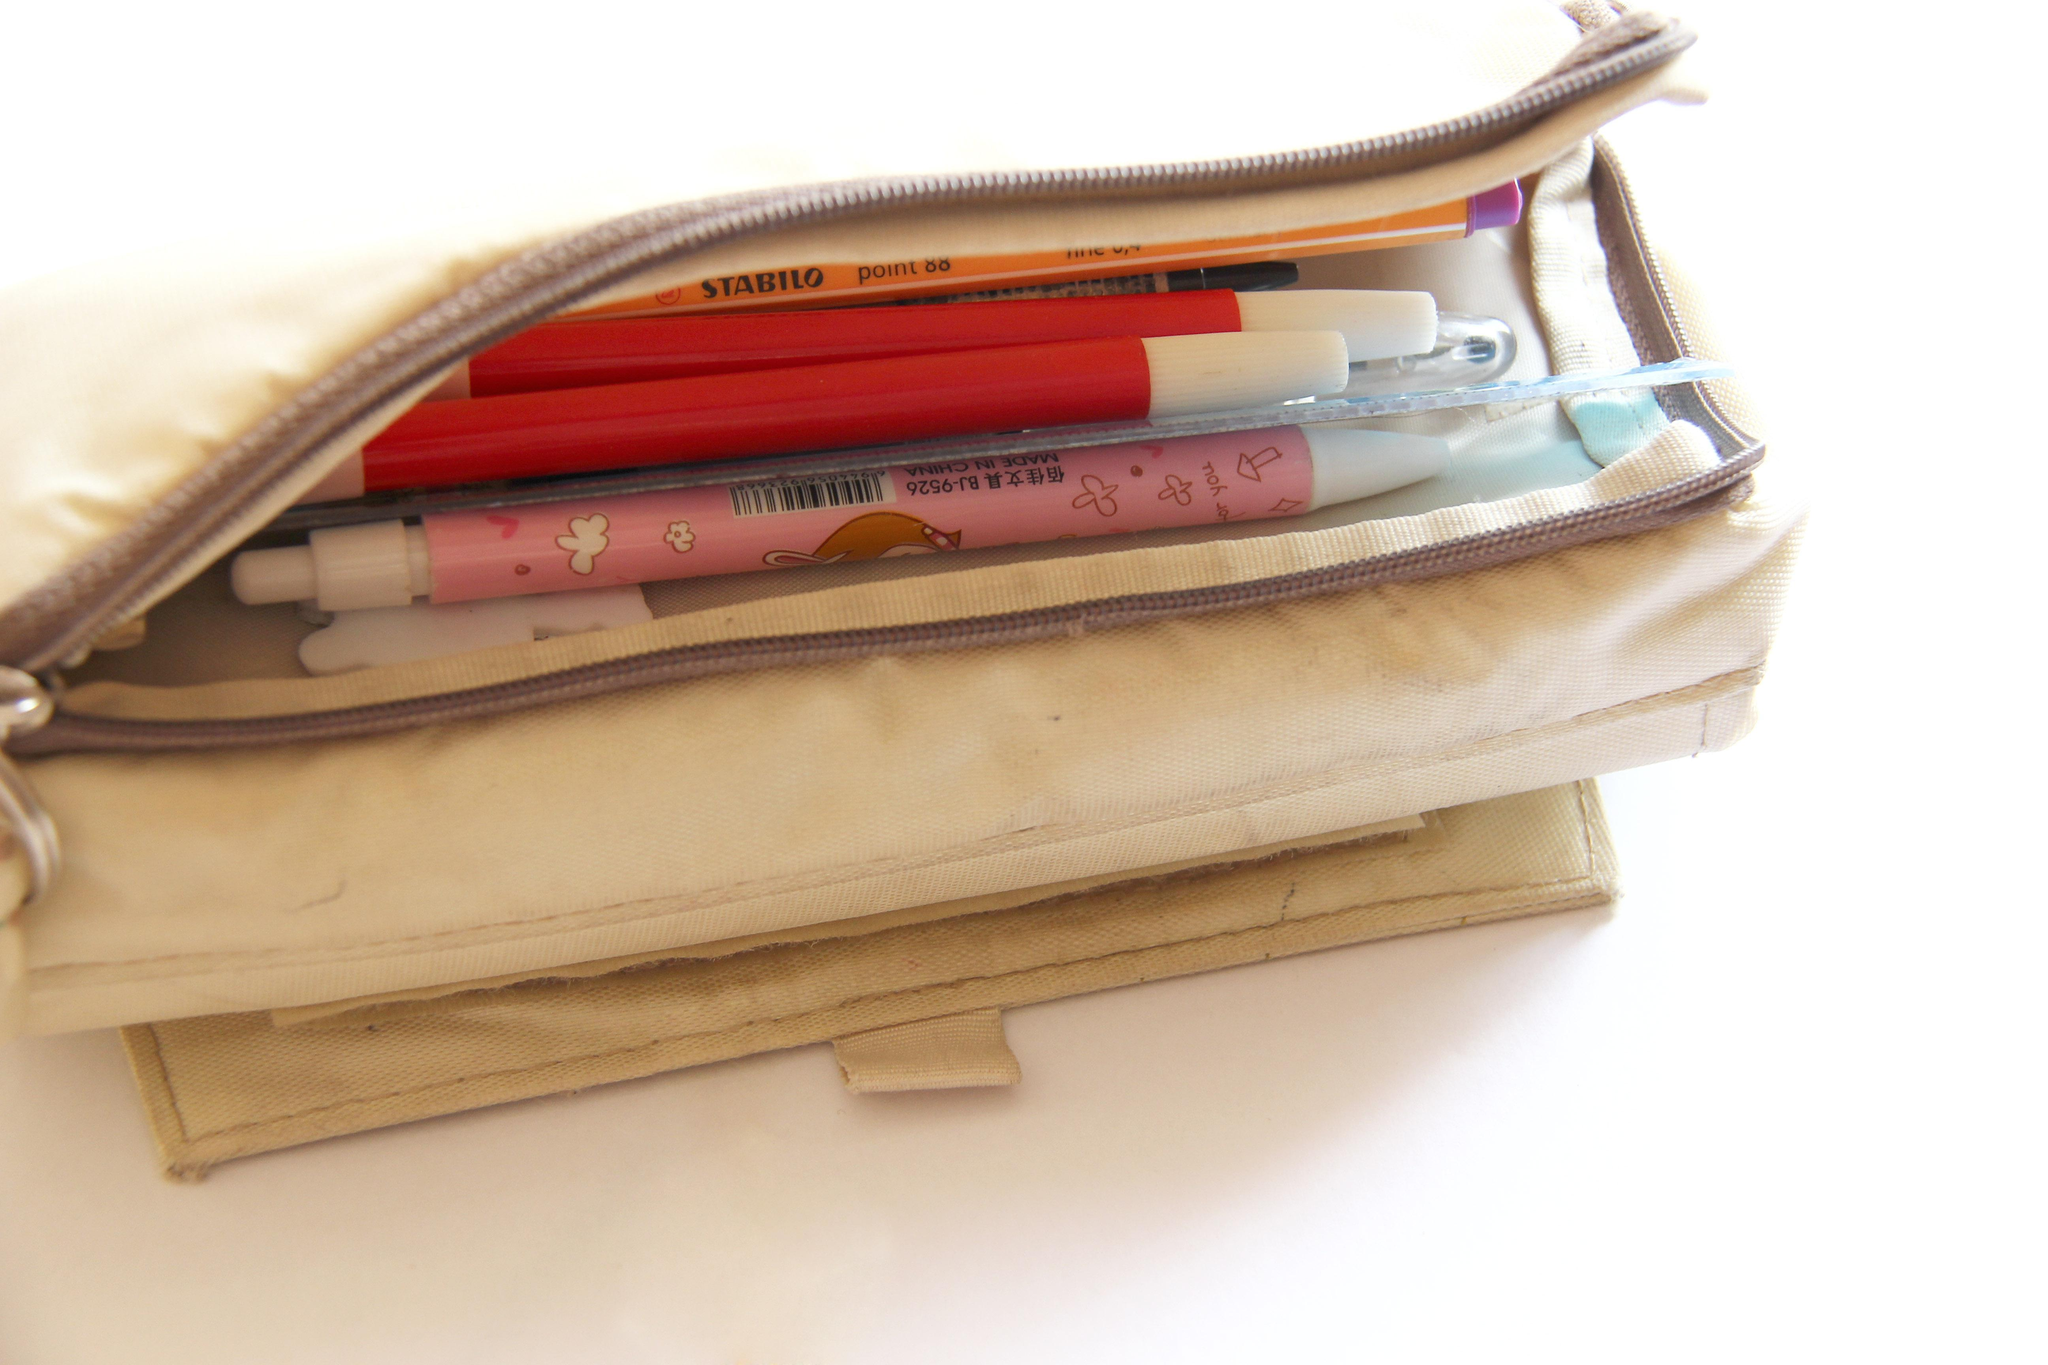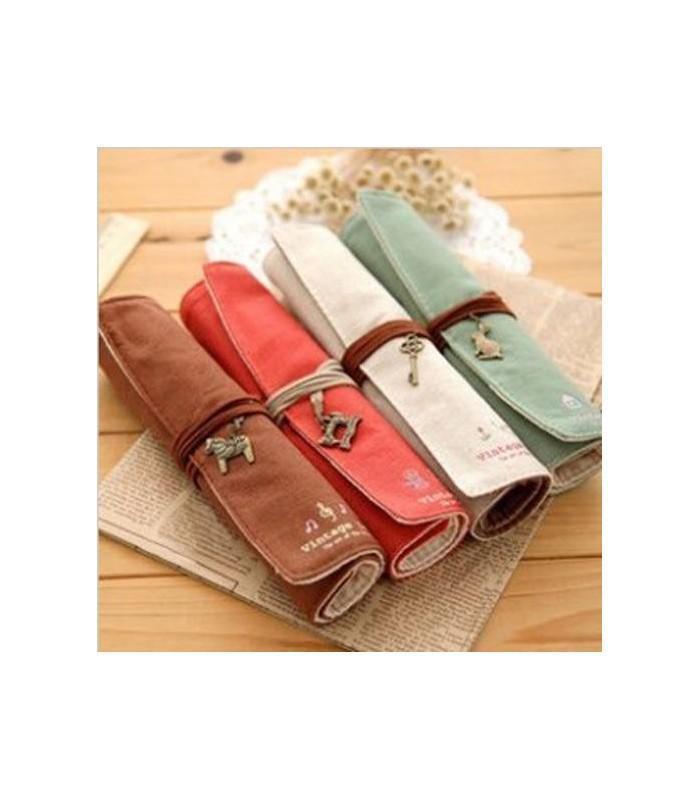The first image is the image on the left, the second image is the image on the right. Considering the images on both sides, is "The left image shows one case with at least some contents visible." valid? Answer yes or no. Yes. 